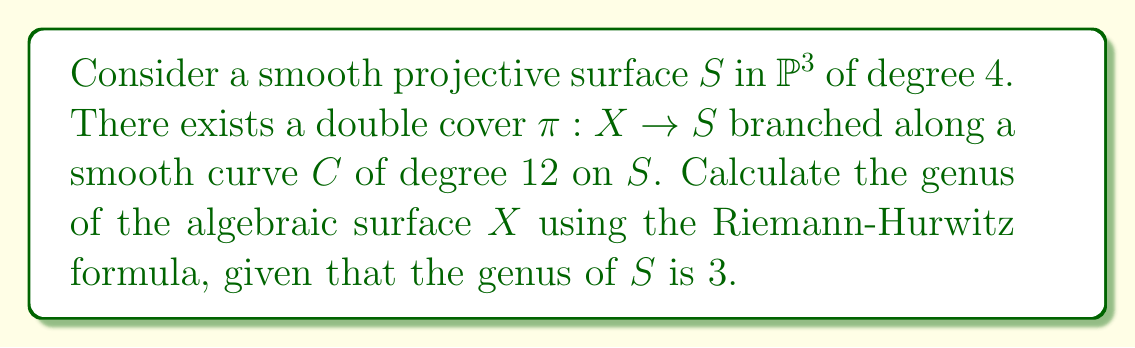Show me your answer to this math problem. Let's approach this step-by-step:

1) First, recall the Riemann-Hurwitz formula for a double cover $\pi: X \rightarrow S$:

   $$2(p_g(X) - q(X) + 1) = 2(p_g(S) - q(S) + 1) + \frac{1}{2}K_S \cdot C + \frac{1}{2}C^2$$

   where $p_g$ is the geometric genus, $q$ is the irregularity, $K_S$ is the canonical divisor of $S$, and $C$ is the branch curve.

2) We're given that the genus of $S$ is 3, so $p_g(S) - q(S) + 1 = 3$.

3) For a smooth surface of degree 4 in $\mathbb{P}^3$, we know that $K_S = \mathcal{O}_S(0)$, so $K_S \cdot C = 0$.

4) To calculate $C^2$, we use the fact that for a curve of degree $d$ on a surface of degree $n$ in $\mathbb{P}^3$, $C^2 = d^2/n$. Here, $d = 12$ and $n = 4$, so:

   $$C^2 = \frac{12^2}{4} = 36$$

5) Substituting these values into the Riemann-Hurwitz formula:

   $$2(p_g(X) - q(X) + 1) = 2(3) + \frac{1}{2}(0) + \frac{1}{2}(36) = 6 + 18 = 24$$

6) Simplifying:

   $$p_g(X) - q(X) + 1 = 12$$

7) The genus of $X$ is defined as $g(X) = p_g(X) - q(X) + 1$, so:

   $$g(X) = 12$$
Answer: $12$ 